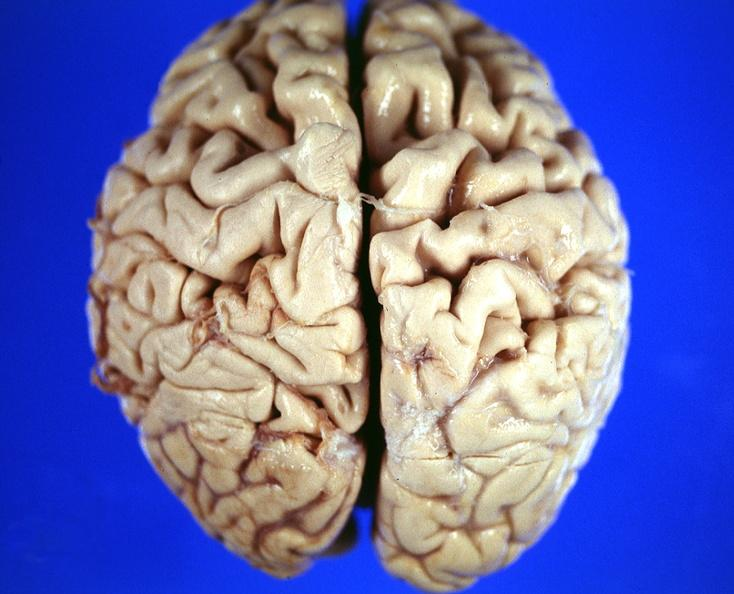what is present?
Answer the question using a single word or phrase. Nervous 